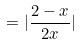<formula> <loc_0><loc_0><loc_500><loc_500>= | \frac { 2 - x } { 2 x } |</formula> 